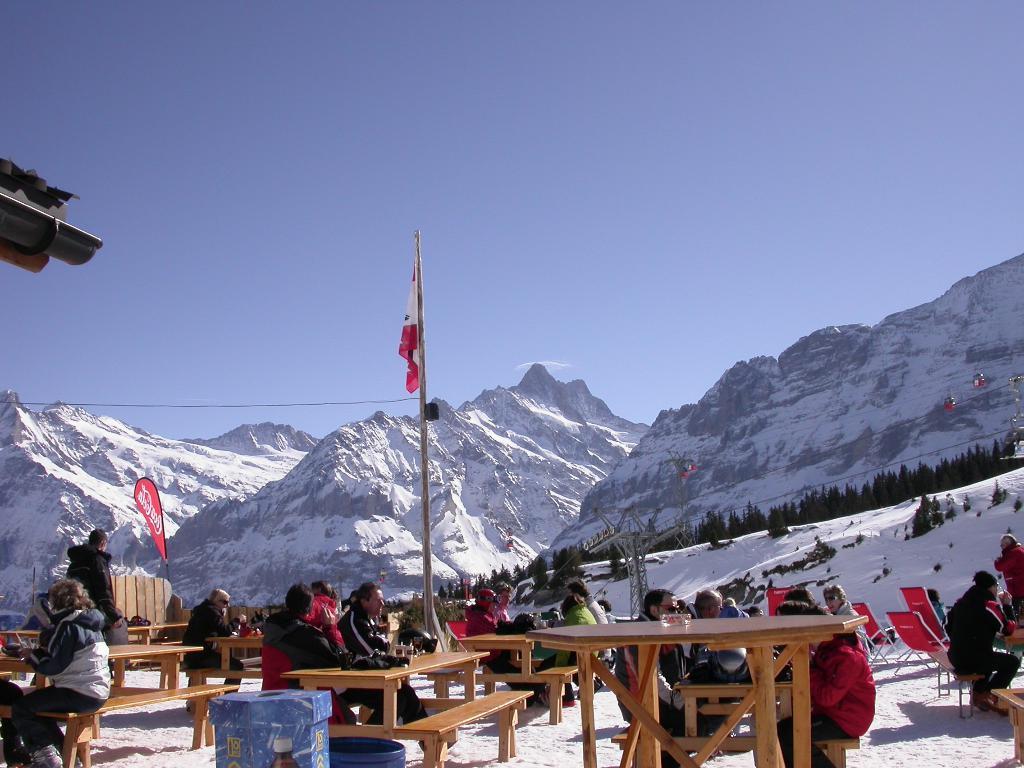Could you give a brief overview of what you see in this image? This is a flag hanging to a pole. I can see groups of people sitting on the benches. This looks like a table with an object on it. I can see two people standing. These are the chairs. I think these are the snowy mountains. I can see the trees. This looks like a ropeway. At the bottom of the image, I can see an object. This is the snow. At the top of the image, I can see the sky. 